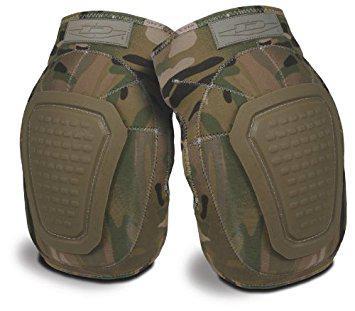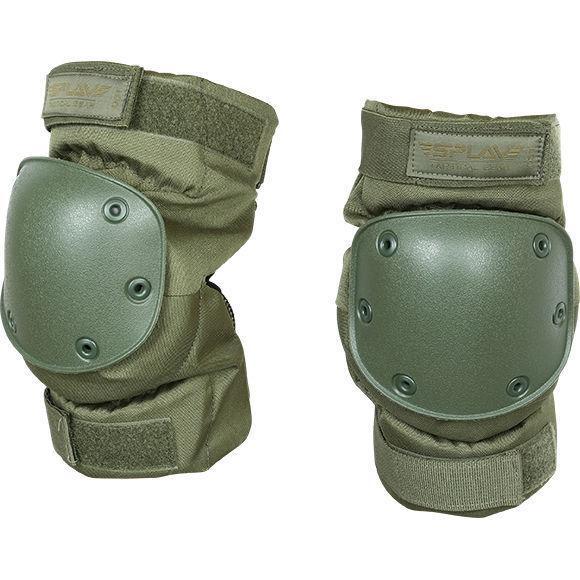The first image is the image on the left, the second image is the image on the right. Assess this claim about the two images: "The knee pads in the left image share the same design.". Correct or not? Answer yes or no. Yes. The first image is the image on the left, the second image is the image on the right. Given the left and right images, does the statement "At least one set of knee pads is green." hold true? Answer yes or no. Yes. 